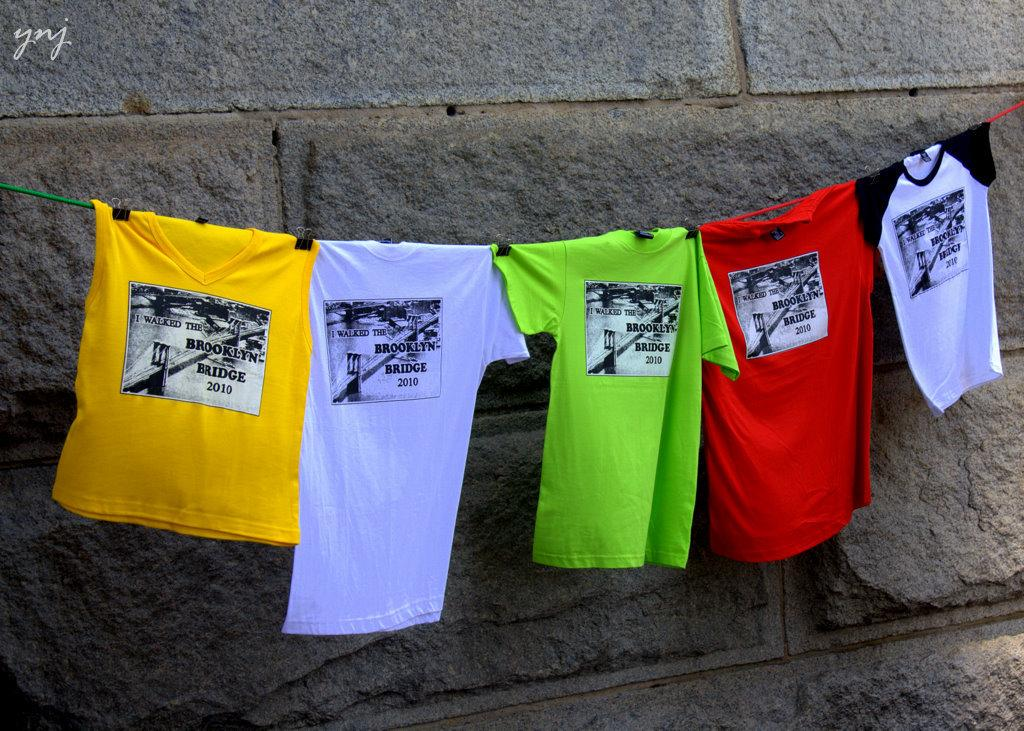<image>
Render a clear and concise summary of the photo. A row of various coloured t shirst hang on a line each with the brooklyn bridge on them 